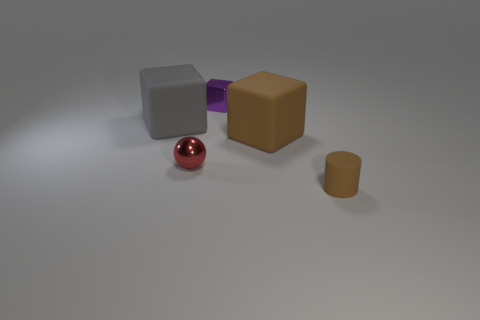There is a large cube that is the same color as the cylinder; what is it made of?
Give a very brief answer. Rubber. Are there any rubber things of the same color as the cylinder?
Offer a very short reply. Yes. Does the large cube that is on the right side of the purple shiny thing have the same color as the tiny cylinder?
Give a very brief answer. Yes. Do the small cylinder and the rubber block that is right of the metallic ball have the same color?
Give a very brief answer. Yes. The tiny object that is both on the right side of the tiny red object and in front of the tiny shiny block is what color?
Your answer should be compact. Brown. How many other objects are the same material as the tiny cube?
Your response must be concise. 1. Are there fewer large brown cubes than small blue matte spheres?
Offer a very short reply. No. Are the gray thing and the thing to the right of the large brown rubber cube made of the same material?
Ensure brevity in your answer.  Yes. What shape is the large object on the left side of the small red metal ball?
Your answer should be very brief. Cube. Is there anything else of the same color as the tiny cylinder?
Your response must be concise. Yes. 